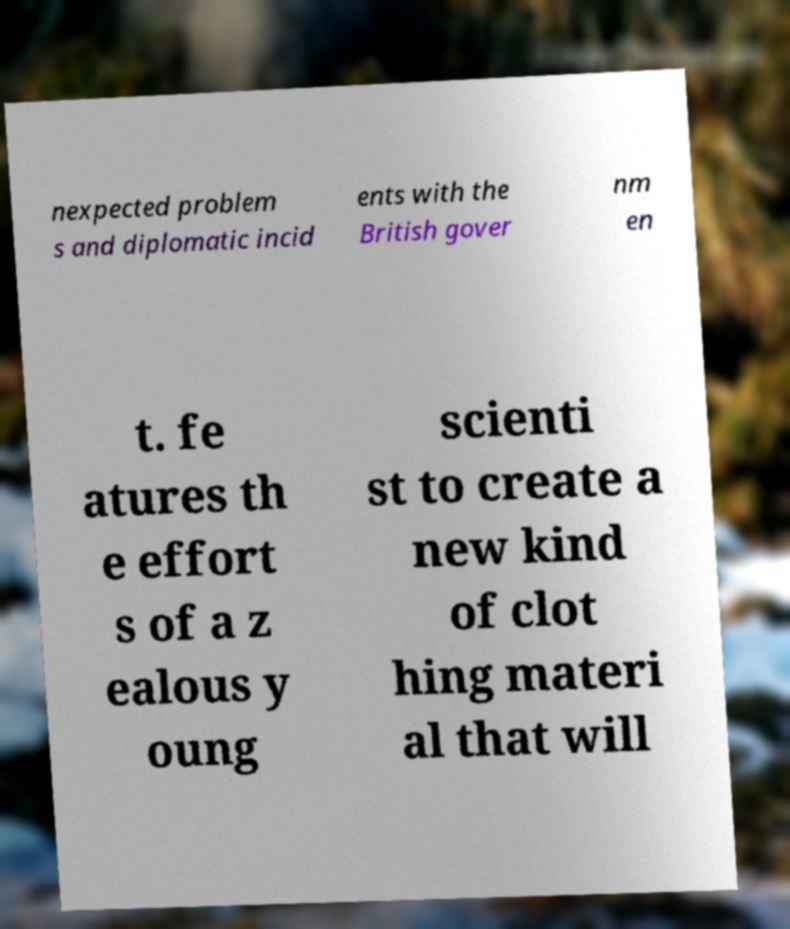Can you accurately transcribe the text from the provided image for me? nexpected problem s and diplomatic incid ents with the British gover nm en t. fe atures th e effort s of a z ealous y oung scienti st to create a new kind of clot hing materi al that will 